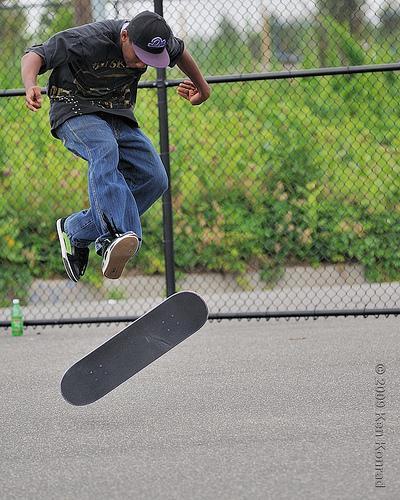How many skateboards are there?
Give a very brief answer. 1. How many fence posts are behind the skateborder?
Give a very brief answer. 1. 